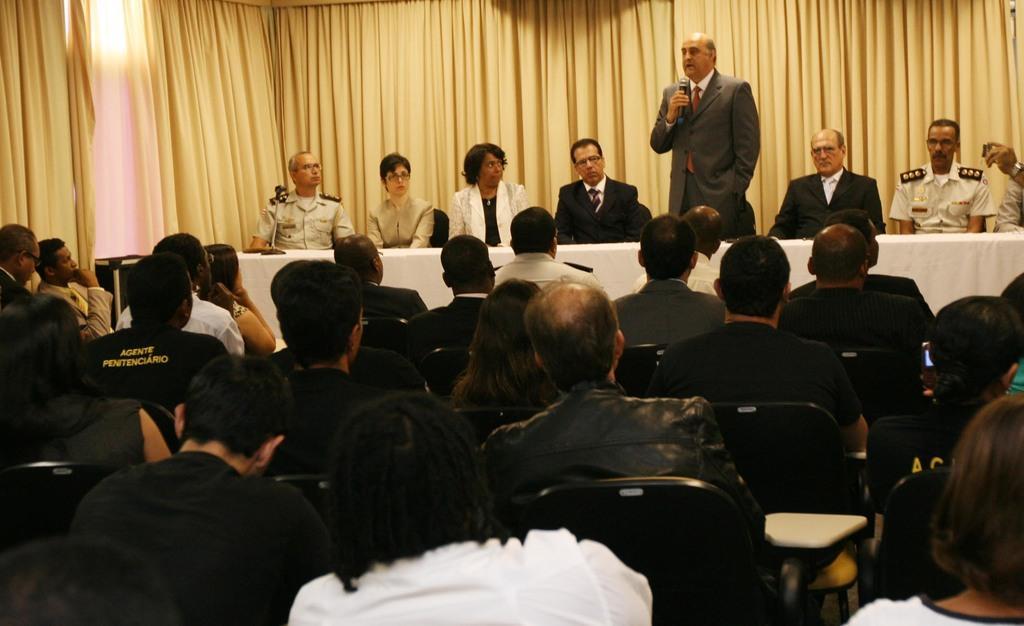Describe this image in one or two sentences. In this picture I can see few people are sitting in the chairs and I can see a man standing and speaking with the help of a microphone and I can see few curtains in the back and I can see a table and a cloth on it. 